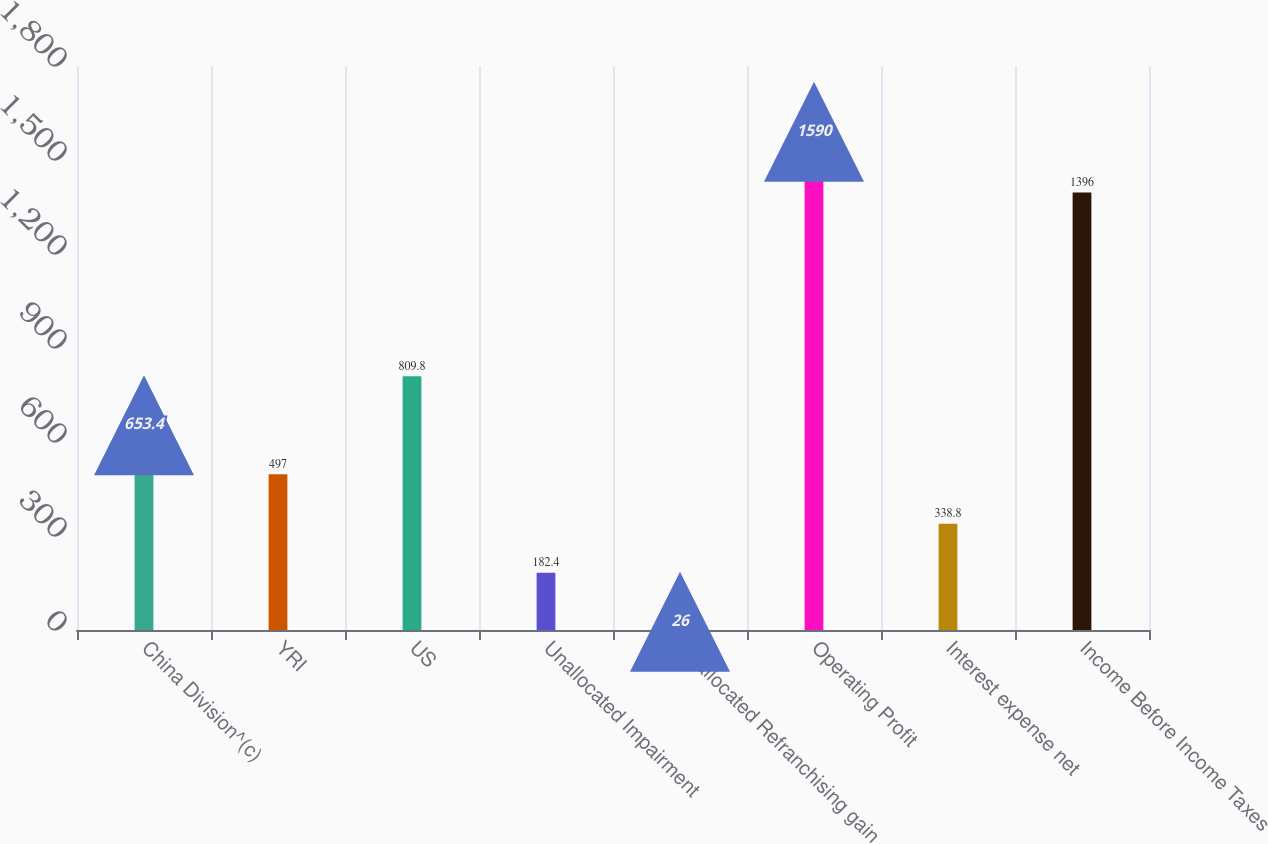Convert chart. <chart><loc_0><loc_0><loc_500><loc_500><bar_chart><fcel>China Division^(c)<fcel>YRI<fcel>US<fcel>Unallocated Impairment<fcel>Unallocated Refranchising gain<fcel>Operating Profit<fcel>Interest expense net<fcel>Income Before Income Taxes<nl><fcel>653.4<fcel>497<fcel>809.8<fcel>182.4<fcel>26<fcel>1590<fcel>338.8<fcel>1396<nl></chart> 